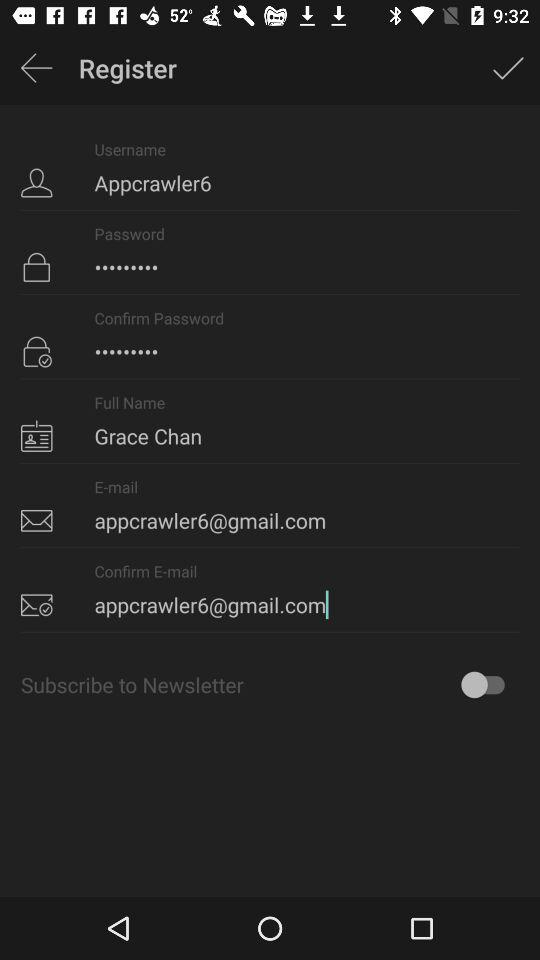What is the status of "Subscribe to Newsletter"? The status of "Subscribe to Newsletter" is "off". 